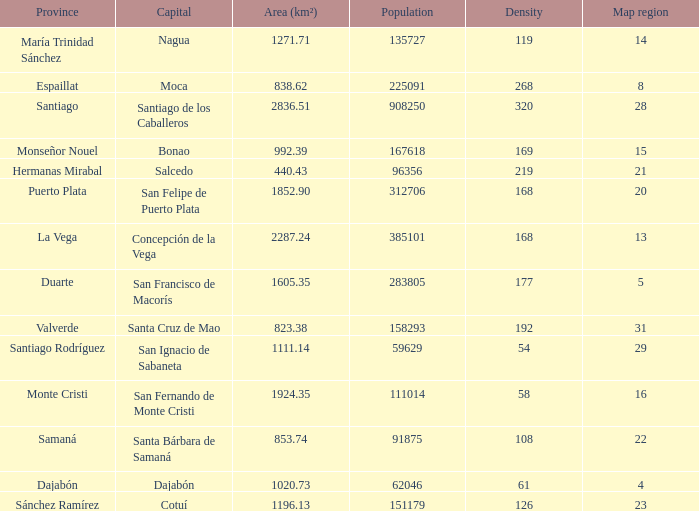Nagua has the area (km²) of? 1271.71. 